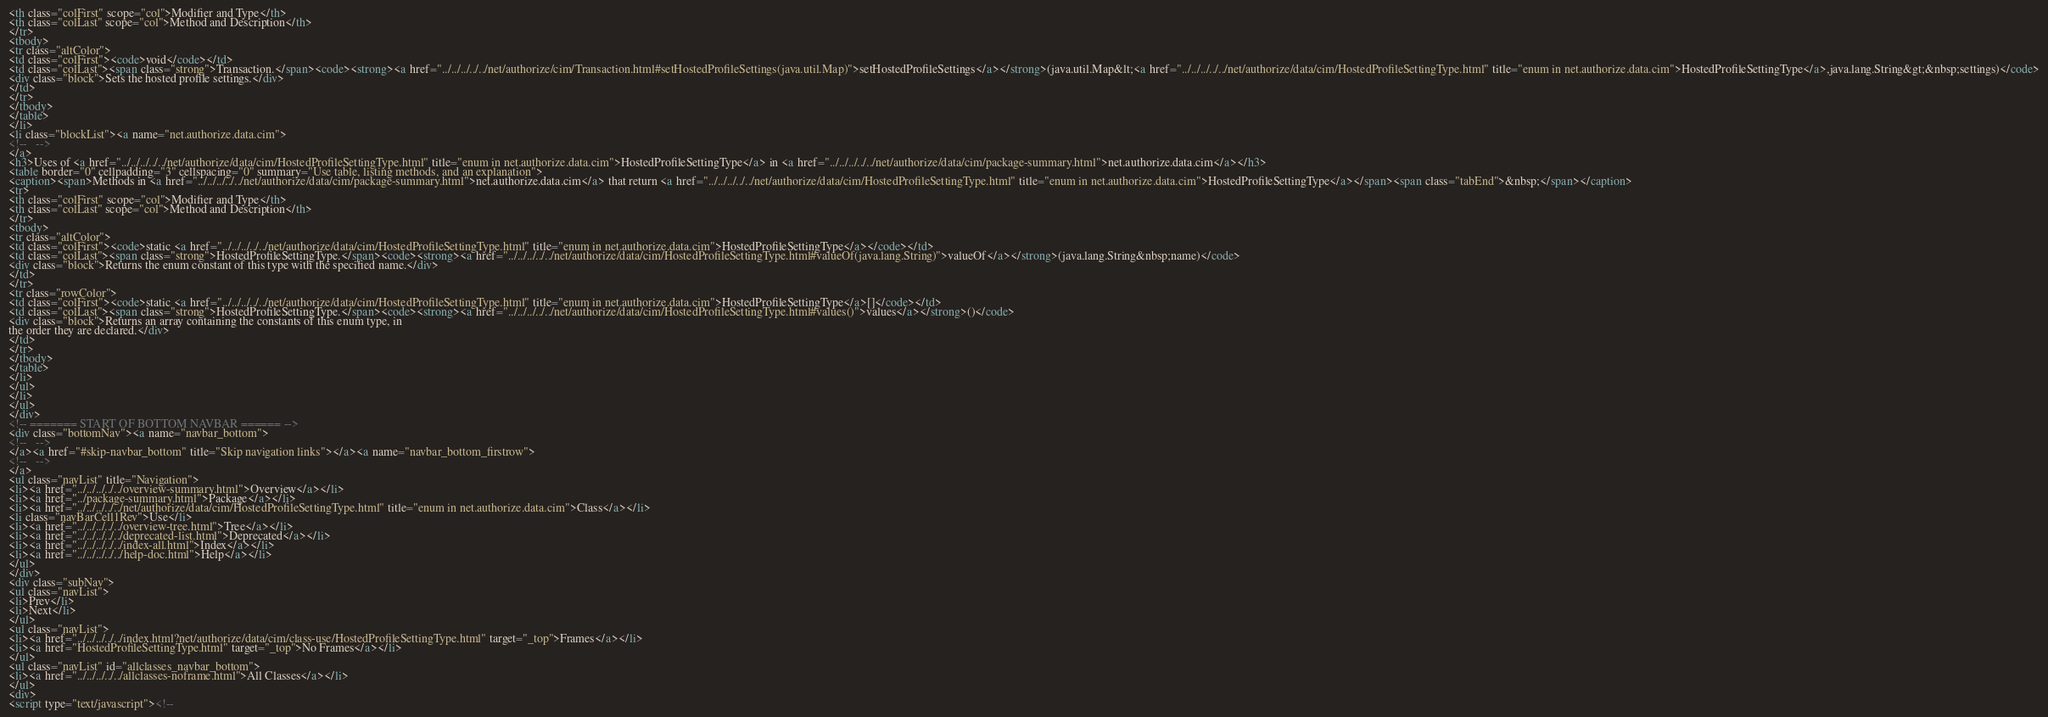Convert code to text. <code><loc_0><loc_0><loc_500><loc_500><_HTML_><th class="colFirst" scope="col">Modifier and Type</th>
<th class="colLast" scope="col">Method and Description</th>
</tr>
<tbody>
<tr class="altColor">
<td class="colFirst"><code>void</code></td>
<td class="colLast"><span class="strong">Transaction.</span><code><strong><a href="../../../../../net/authorize/cim/Transaction.html#setHostedProfileSettings(java.util.Map)">setHostedProfileSettings</a></strong>(java.util.Map&lt;<a href="../../../../../net/authorize/data/cim/HostedProfileSettingType.html" title="enum in net.authorize.data.cim">HostedProfileSettingType</a>,java.lang.String&gt;&nbsp;settings)</code>
<div class="block">Sets the hosted profile settings.</div>
</td>
</tr>
</tbody>
</table>
</li>
<li class="blockList"><a name="net.authorize.data.cim">
<!--   -->
</a>
<h3>Uses of <a href="../../../../../net/authorize/data/cim/HostedProfileSettingType.html" title="enum in net.authorize.data.cim">HostedProfileSettingType</a> in <a href="../../../../../net/authorize/data/cim/package-summary.html">net.authorize.data.cim</a></h3>
<table border="0" cellpadding="3" cellspacing="0" summary="Use table, listing methods, and an explanation">
<caption><span>Methods in <a href="../../../../../net/authorize/data/cim/package-summary.html">net.authorize.data.cim</a> that return <a href="../../../../../net/authorize/data/cim/HostedProfileSettingType.html" title="enum in net.authorize.data.cim">HostedProfileSettingType</a></span><span class="tabEnd">&nbsp;</span></caption>
<tr>
<th class="colFirst" scope="col">Modifier and Type</th>
<th class="colLast" scope="col">Method and Description</th>
</tr>
<tbody>
<tr class="altColor">
<td class="colFirst"><code>static <a href="../../../../../net/authorize/data/cim/HostedProfileSettingType.html" title="enum in net.authorize.data.cim">HostedProfileSettingType</a></code></td>
<td class="colLast"><span class="strong">HostedProfileSettingType.</span><code><strong><a href="../../../../../net/authorize/data/cim/HostedProfileSettingType.html#valueOf(java.lang.String)">valueOf</a></strong>(java.lang.String&nbsp;name)</code>
<div class="block">Returns the enum constant of this type with the specified name.</div>
</td>
</tr>
<tr class="rowColor">
<td class="colFirst"><code>static <a href="../../../../../net/authorize/data/cim/HostedProfileSettingType.html" title="enum in net.authorize.data.cim">HostedProfileSettingType</a>[]</code></td>
<td class="colLast"><span class="strong">HostedProfileSettingType.</span><code><strong><a href="../../../../../net/authorize/data/cim/HostedProfileSettingType.html#values()">values</a></strong>()</code>
<div class="block">Returns an array containing the constants of this enum type, in
the order they are declared.</div>
</td>
</tr>
</tbody>
</table>
</li>
</ul>
</li>
</ul>
</div>
<!-- ======= START OF BOTTOM NAVBAR ====== -->
<div class="bottomNav"><a name="navbar_bottom">
<!--   -->
</a><a href="#skip-navbar_bottom" title="Skip navigation links"></a><a name="navbar_bottom_firstrow">
<!--   -->
</a>
<ul class="navList" title="Navigation">
<li><a href="../../../../../overview-summary.html">Overview</a></li>
<li><a href="../package-summary.html">Package</a></li>
<li><a href="../../../../../net/authorize/data/cim/HostedProfileSettingType.html" title="enum in net.authorize.data.cim">Class</a></li>
<li class="navBarCell1Rev">Use</li>
<li><a href="../../../../../overview-tree.html">Tree</a></li>
<li><a href="../../../../../deprecated-list.html">Deprecated</a></li>
<li><a href="../../../../../index-all.html">Index</a></li>
<li><a href="../../../../../help-doc.html">Help</a></li>
</ul>
</div>
<div class="subNav">
<ul class="navList">
<li>Prev</li>
<li>Next</li>
</ul>
<ul class="navList">
<li><a href="../../../../../index.html?net/authorize/data/cim/class-use/HostedProfileSettingType.html" target="_top">Frames</a></li>
<li><a href="HostedProfileSettingType.html" target="_top">No Frames</a></li>
</ul>
<ul class="navList" id="allclasses_navbar_bottom">
<li><a href="../../../../../allclasses-noframe.html">All Classes</a></li>
</ul>
<div>
<script type="text/javascript"><!--</code> 